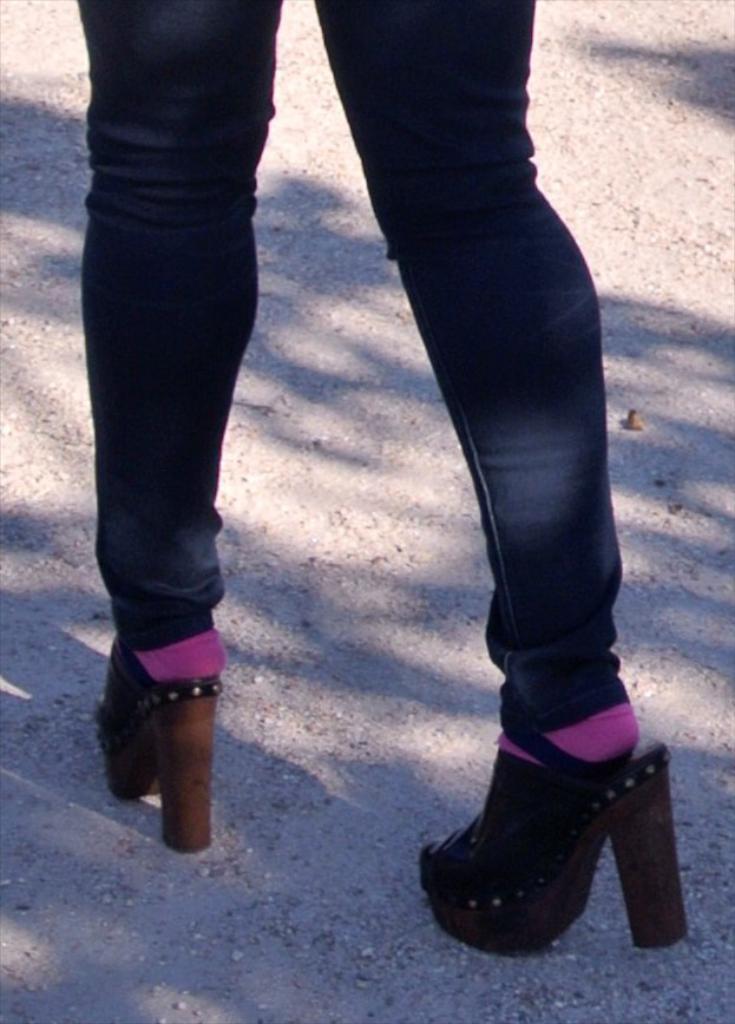Can you describe this image briefly? In this picture I can see there is a woman walking and she is wearing a black pant, purple socks and there are high sandals and on the floor I can see there is soil. 